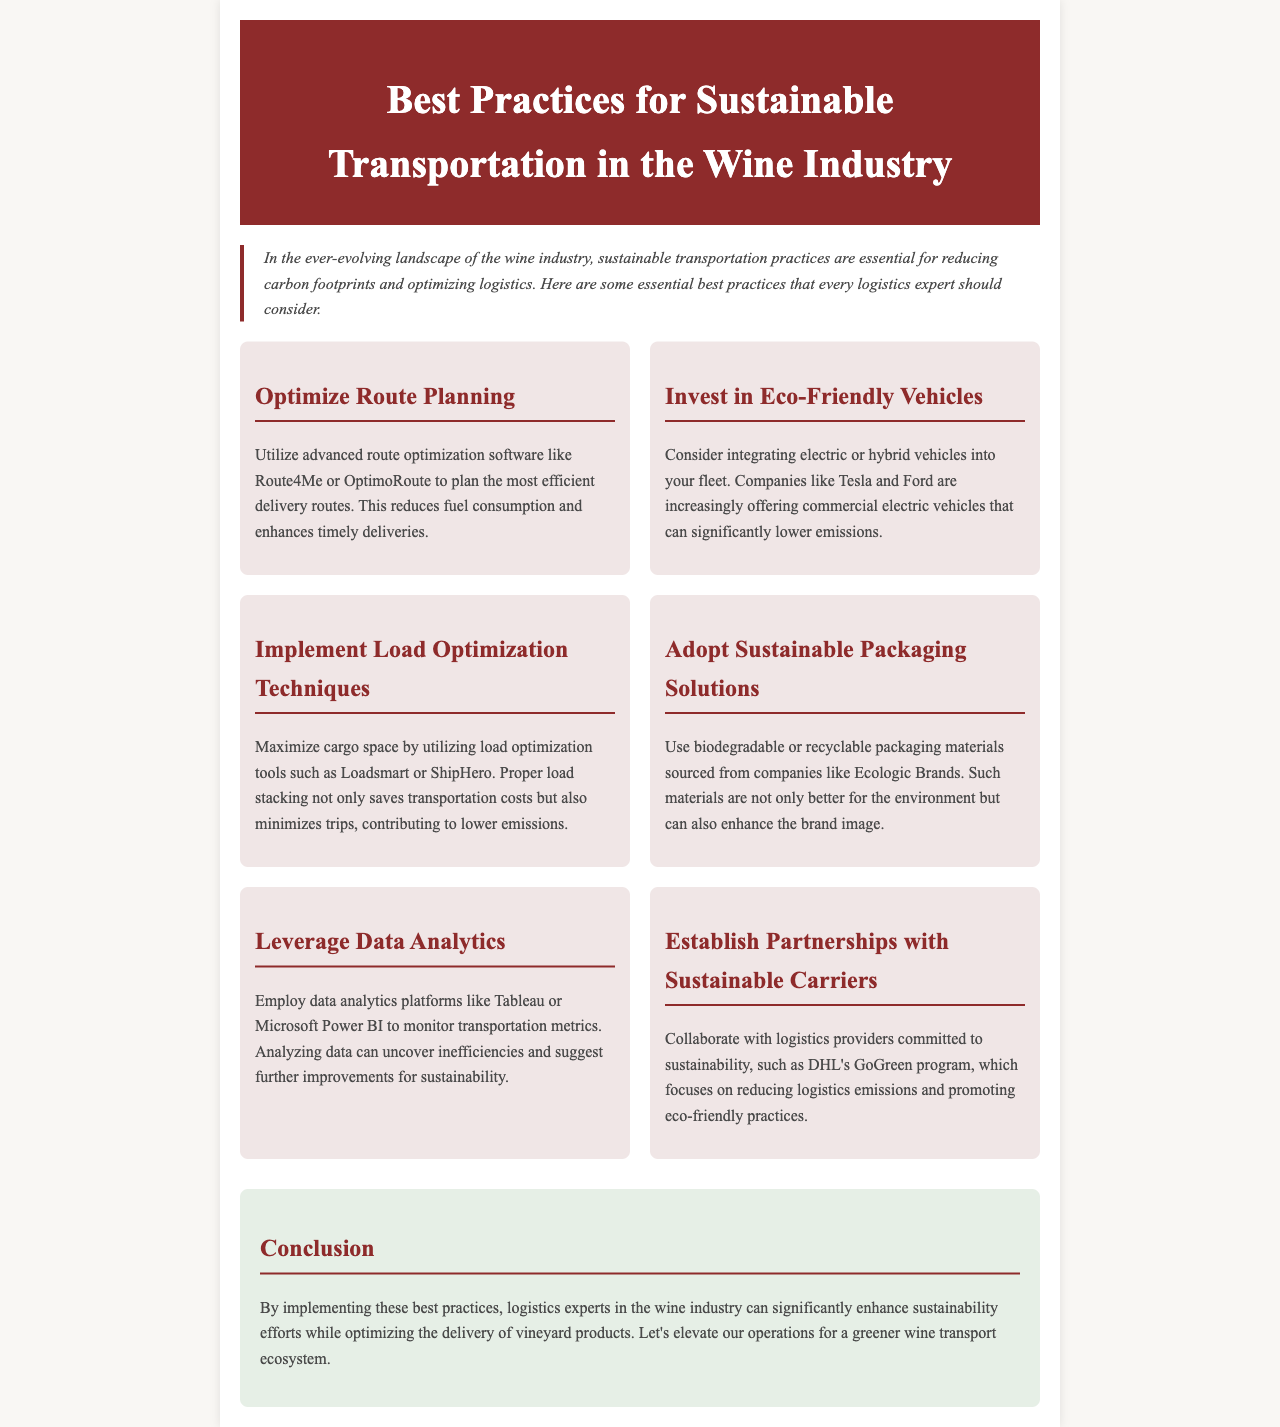What is the title of the newsletter? The title is prominently displayed at the top of the document in the header section.
Answer: Best Practices for Sustainable Transportation in the Wine Industry What practice involves utilizing advanced software? The document includes a section specifically on optimizing route planning, which mentions the use of software.
Answer: Optimize Route Planning Which vehicle type should logistics experts consider for sustainability? This information is found in the section about vehicle investment focused on reducing emissions.
Answer: Electric or hybrid vehicles What tool helps maximize cargo space? The document specifies load optimization techniques and the use of certain tools for this purpose.
Answer: Load optimization tools What program is mentioned for collaborating with carriers? This refers to the specific initiative by a logistics provider to support sustainable practices detailed in the document.
Answer: DHL's GoGreen program What is the expected outcome of implementing sustainable practices? The conclusion summarizes the benefits of these practices for logistics experts in the wine industry.
Answer: Enhance sustainability efforts Which section discusses packaging solutions? This question refers to a specific area in the document that addresses material use in shipping.
Answer: Adopt Sustainable Packaging Solutions What platform can be used for monitoring transportation metrics? Data analytics platforms are referenced in the content for the purpose of analyzing transportation performance.
Answer: Tableau or Microsoft Power BI What is one characteristic of the vehicles suggested? The document highlights specific features of the suggested vehicles for sustainability purposes.
Answer: Eco-friendly 